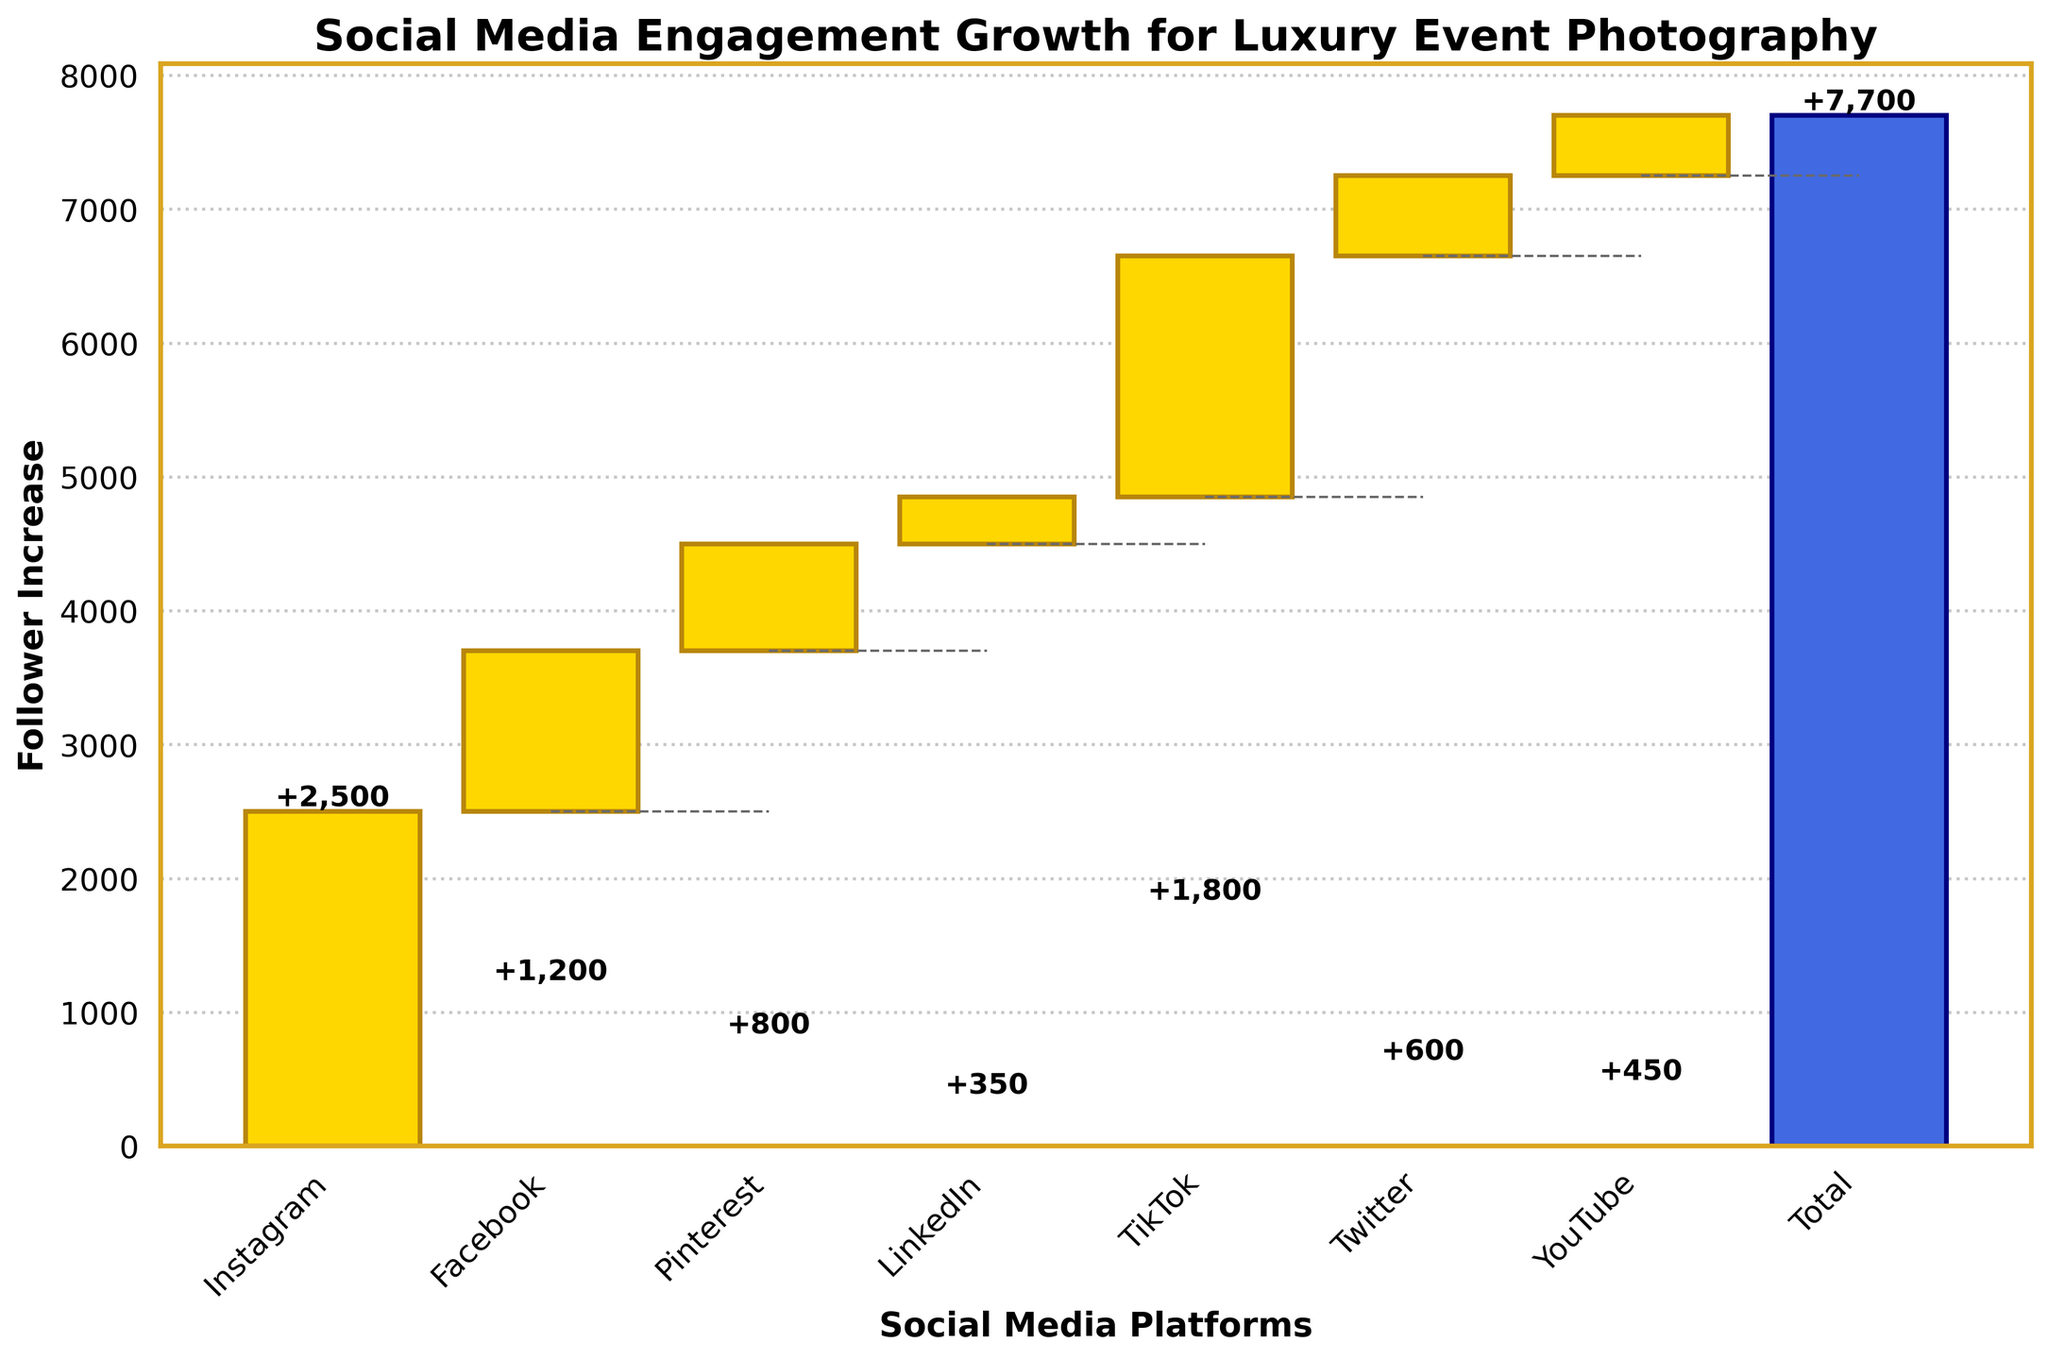What's the title of the chart? The chart's title is displayed at the top of the chart.
Answer: Social Media Engagement Growth for Luxury Event Photography Which platform shows the highest increase in followers? To find the platform with the highest follower increase, look at the bar that extends the highest.
Answer: Instagram What's the total increase in followers across all platforms? The total increase is shown by the last bar labeled 'Total'.
Answer: 7700 How many followers did Pinterest increase by? Identify the bar labeled 'Pinterest' and read the number at the top of it.
Answer: 800 Which platform has the smallest follower increase? Compare the heights of all bars; the smallest one indicates the smallest increase.
Answer: LinkedIn What is the combined increase in followers for LinkedIn, Twitter, and YouTube? Add the follower increases for LinkedIn (350), Twitter (600), and YouTube (450).
Answer: 1400 How much more did TikTok's followers increase compared to LinkedIn's? Subtract LinkedIn's follower increase (350) from TikTok's (1800).
Answer: 1450 Did Twitter gain more followers than Pinterest? Compare the heights of the bars for Twitter and Pinterest to see which is higher.
Answer: No How many platforms gained fewer than 1000 followers? Count the platforms with bars representing follower increases less than 1000.
Answer: 4 What percentage of the total increase is contributed by Instagram? Divide Instagram's increase (2500) by the total increase (7700) and multiply by 100 to get the percentage.
Answer: 32.47% 